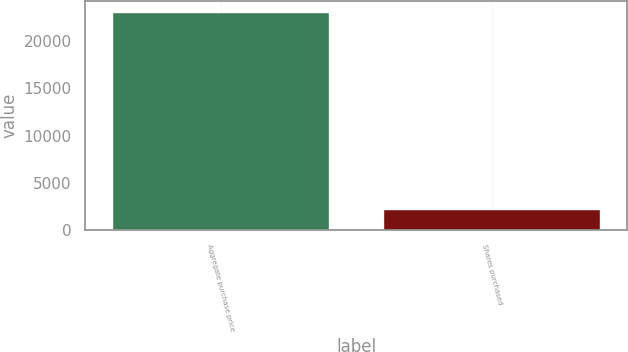Convert chart to OTSL. <chart><loc_0><loc_0><loc_500><loc_500><bar_chart><fcel>Aggregate purchase price<fcel>Shares purchased<nl><fcel>23079<fcel>2262<nl></chart> 